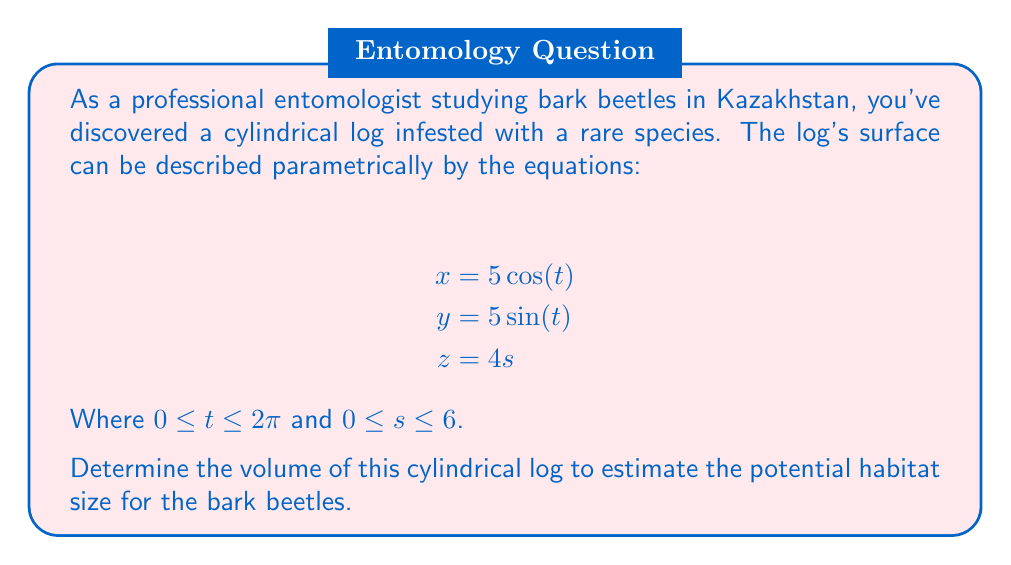Help me with this question. To find the volume of the cylindrical log, we need to follow these steps:

1) First, we need to identify the radius and height of the cylinder from the parametric equations:

   - The equations for $x$ and $y$ describe a circle in the xy-plane with radius 5 units.
   - The equation for $z$ describes the height of the cylinder, which goes from 0 to 24 units (when $s$ goes from 0 to 6).

2) The volume of a cylinder is given by the formula:

   $$V = \pi r^2 h$$

   Where $r$ is the radius of the base and $h$ is the height of the cylinder.

3) We can identify from our parametric equations:
   
   $r = 5$ (from the equations for $x$ and $y$)
   $h = 24$ (from the equation for $z$ when $s = 6$)

4) Now, let's substitute these values into our volume formula:

   $$V = \pi (5)^2 (24)$$

5) Simplify:

   $$V = \pi (25) (24) = 600\pi$$

Therefore, the volume of the cylindrical log is $600\pi$ cubic units.
Answer: $600\pi$ cubic units 